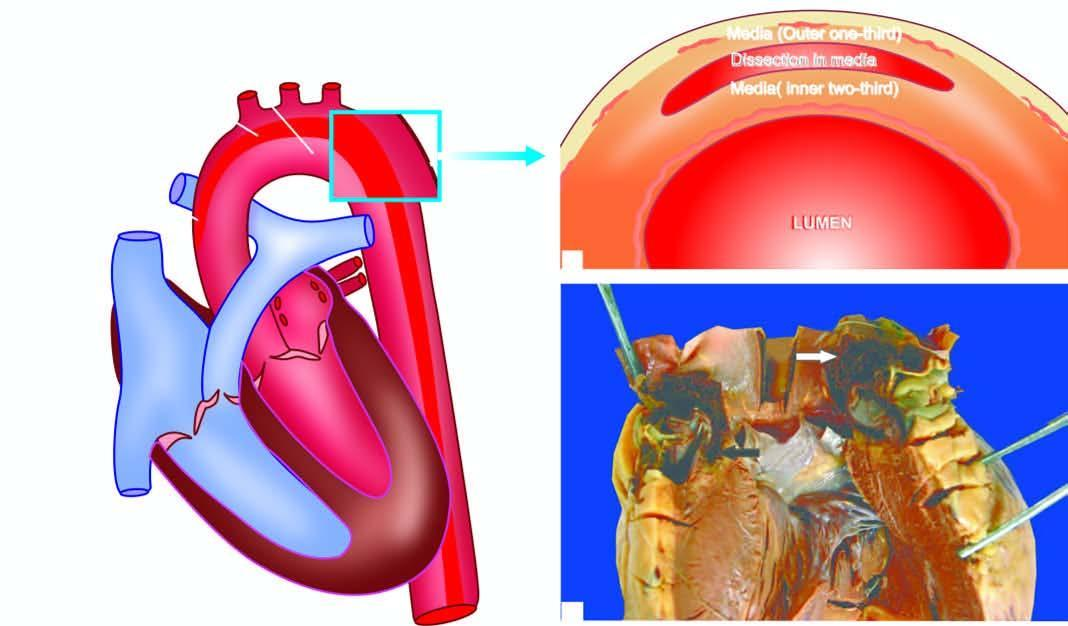s there an intimal tear in the aortic wall extending proximally upto aortic valve dissecting the media which contains clotted blood?
Answer the question using a single word or phrase. Yes 